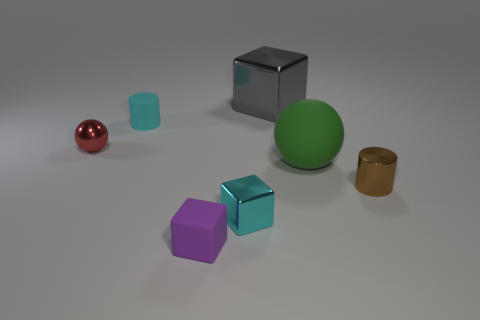The ball that is the same material as the cyan cube is what color?
Provide a succinct answer. Red. Does the big green object have the same shape as the tiny purple matte thing?
Provide a succinct answer. No. How many things are both behind the red metallic ball and in front of the large gray thing?
Your response must be concise. 1. How many rubber things are either cyan cylinders or brown objects?
Make the answer very short. 1. There is a cylinder left of the cylinder that is in front of the red object; what size is it?
Give a very brief answer. Small. What material is the object that is the same color as the small metallic cube?
Offer a very short reply. Rubber. Are there any cyan things that are on the left side of the small block on the right side of the rubber object that is in front of the rubber sphere?
Give a very brief answer. Yes. Are the sphere on the right side of the large block and the cylinder that is to the left of the big gray shiny block made of the same material?
Keep it short and to the point. Yes. What number of things are balls or small cubes on the right side of the tiny purple object?
Offer a terse response. 3. What number of tiny cyan things are the same shape as the small brown metal object?
Your response must be concise. 1. 